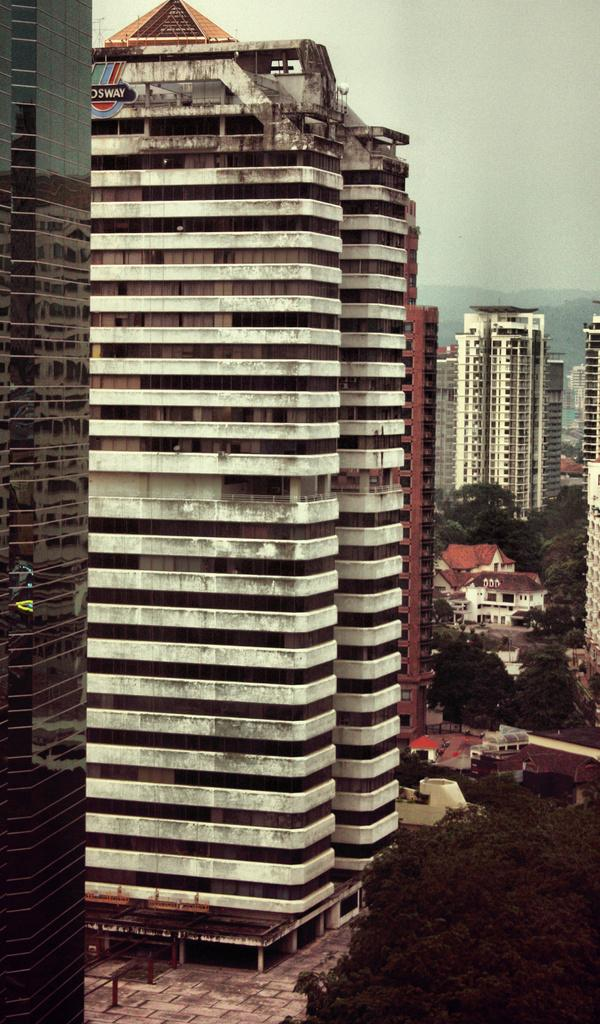What type of structures are present in the image? There is a group of buildings in the image. What else can be seen in the image besides the buildings? There are poles and a group of trees visible in the image. What type of natural feature is visible in the image? The hills are visible in the image. How would you describe the weather in the image? The sky is cloudy in the image. What type of lace can be seen on the buildings in the image? There is no lace present on the buildings in the image. How does the faucet in the image draw attention to itself? There is no faucet present in the image. 